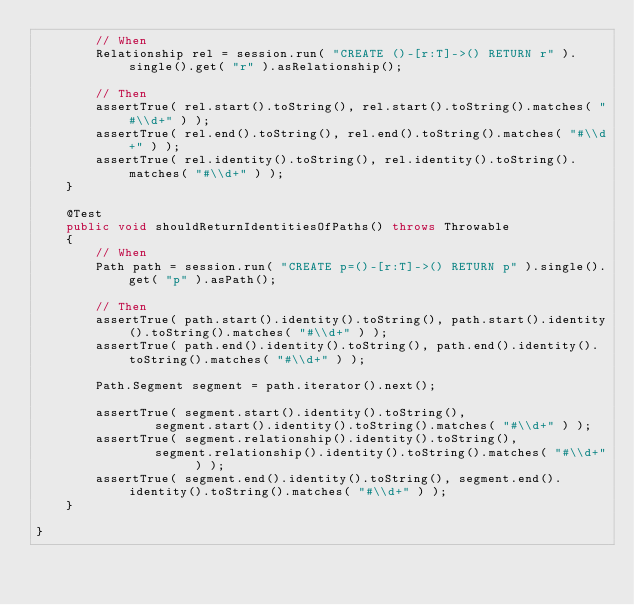<code> <loc_0><loc_0><loc_500><loc_500><_Java_>        // When
        Relationship rel = session.run( "CREATE ()-[r:T]->() RETURN r" ).single().get( "r" ).asRelationship();

        // Then
        assertTrue( rel.start().toString(), rel.start().toString().matches( "#\\d+" ) );
        assertTrue( rel.end().toString(), rel.end().toString().matches( "#\\d+" ) );
        assertTrue( rel.identity().toString(), rel.identity().toString().matches( "#\\d+" ) );
    }

    @Test
    public void shouldReturnIdentitiesOfPaths() throws Throwable
    {
        // When
        Path path = session.run( "CREATE p=()-[r:T]->() RETURN p" ).single().get( "p" ).asPath();

        // Then
        assertTrue( path.start().identity().toString(), path.start().identity().toString().matches( "#\\d+" ) );
        assertTrue( path.end().identity().toString(), path.end().identity().toString().matches( "#\\d+" ) );

        Path.Segment segment = path.iterator().next();

        assertTrue( segment.start().identity().toString(),
                segment.start().identity().toString().matches( "#\\d+" ) );
        assertTrue( segment.relationship().identity().toString(),
                segment.relationship().identity().toString().matches( "#\\d+" ) );
        assertTrue( segment.end().identity().toString(), segment.end().identity().toString().matches( "#\\d+" ) );
    }

}
</code> 